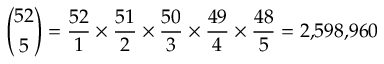<formula> <loc_0><loc_0><loc_500><loc_500>{ \binom { 5 2 } { 5 } } = { \frac { 5 2 } { 1 } } \times { \frac { 5 1 } { 2 } } \times { \frac { 5 0 } { 3 } } \times { \frac { 4 9 } { 4 } } \times { \frac { 4 8 } { 5 } } = 2 { , } 5 9 8 { , } 9 6 0</formula> 